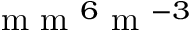<formula> <loc_0><loc_0><loc_500><loc_500>m m ^ { 6 } m ^ { - 3 }</formula> 